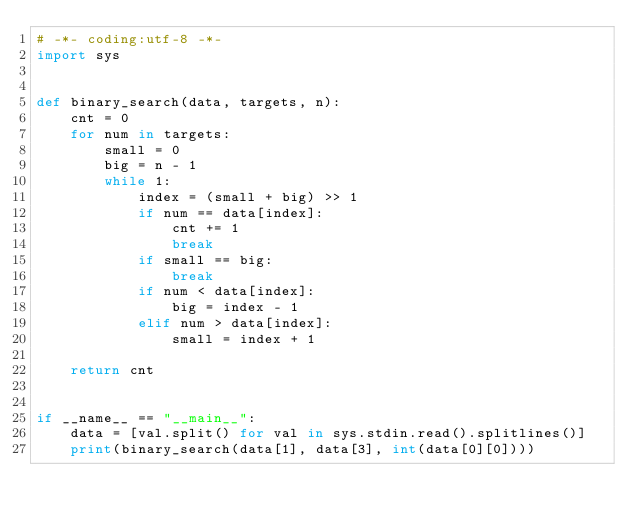Convert code to text. <code><loc_0><loc_0><loc_500><loc_500><_Python_># -*- coding:utf-8 -*-
import sys


def binary_search(data, targets, n):
    cnt = 0
    for num in targets:
        small = 0
        big = n - 1
        while 1:
            index = (small + big) >> 1
            if num == data[index]:
                cnt += 1
                break
            if small == big:
                break
            if num < data[index]:
                big = index - 1
            elif num > data[index]:
                small = index + 1

    return cnt


if __name__ == "__main__":
    data = [val.split() for val in sys.stdin.read().splitlines()]
    print(binary_search(data[1], data[3], int(data[0][0])))</code> 